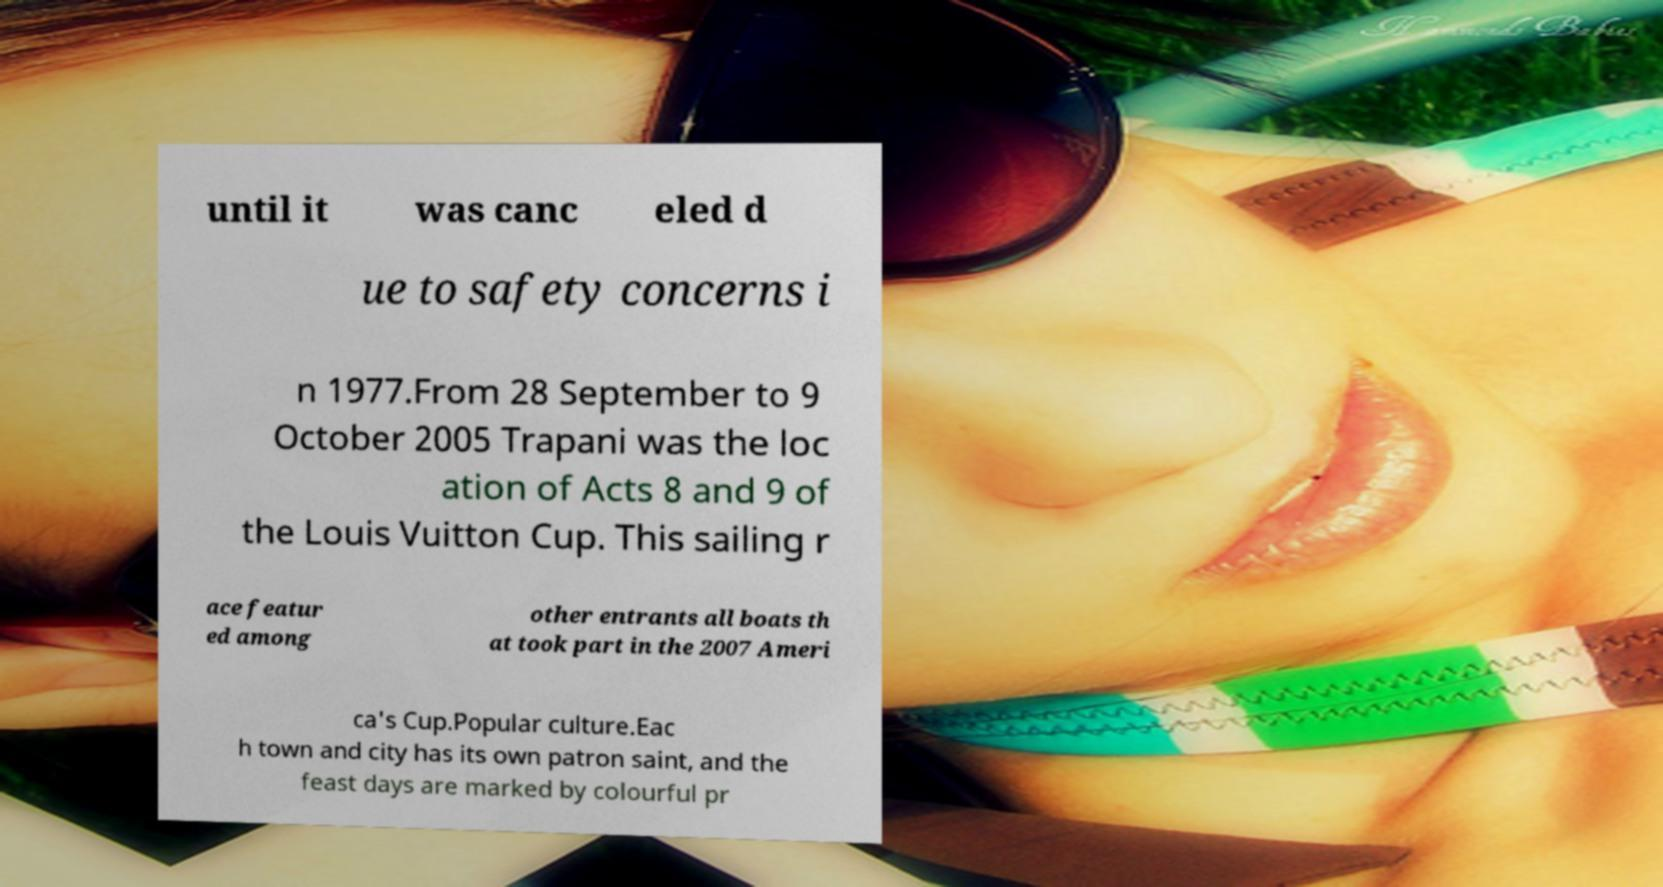For documentation purposes, I need the text within this image transcribed. Could you provide that? until it was canc eled d ue to safety concerns i n 1977.From 28 September to 9 October 2005 Trapani was the loc ation of Acts 8 and 9 of the Louis Vuitton Cup. This sailing r ace featur ed among other entrants all boats th at took part in the 2007 Ameri ca's Cup.Popular culture.Eac h town and city has its own patron saint, and the feast days are marked by colourful pr 